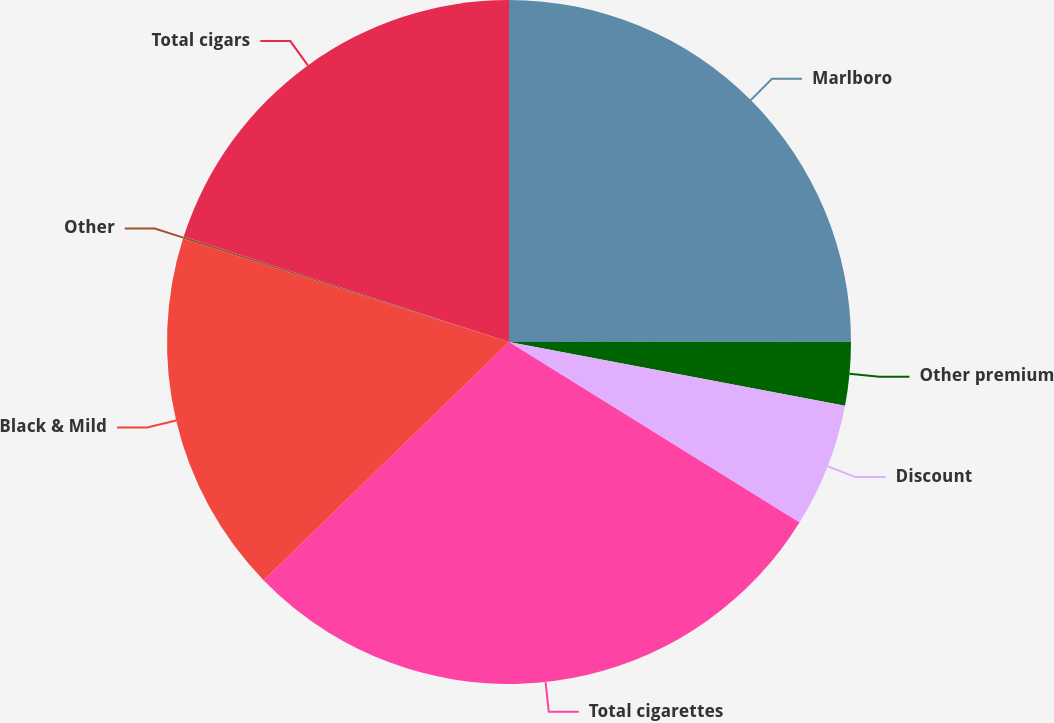Convert chart to OTSL. <chart><loc_0><loc_0><loc_500><loc_500><pie_chart><fcel>Marlboro<fcel>Other premium<fcel>Discount<fcel>Total cigarettes<fcel>Black & Mild<fcel>Other<fcel>Total cigars<nl><fcel>24.99%<fcel>2.99%<fcel>5.87%<fcel>28.89%<fcel>17.14%<fcel>0.11%<fcel>20.01%<nl></chart> 